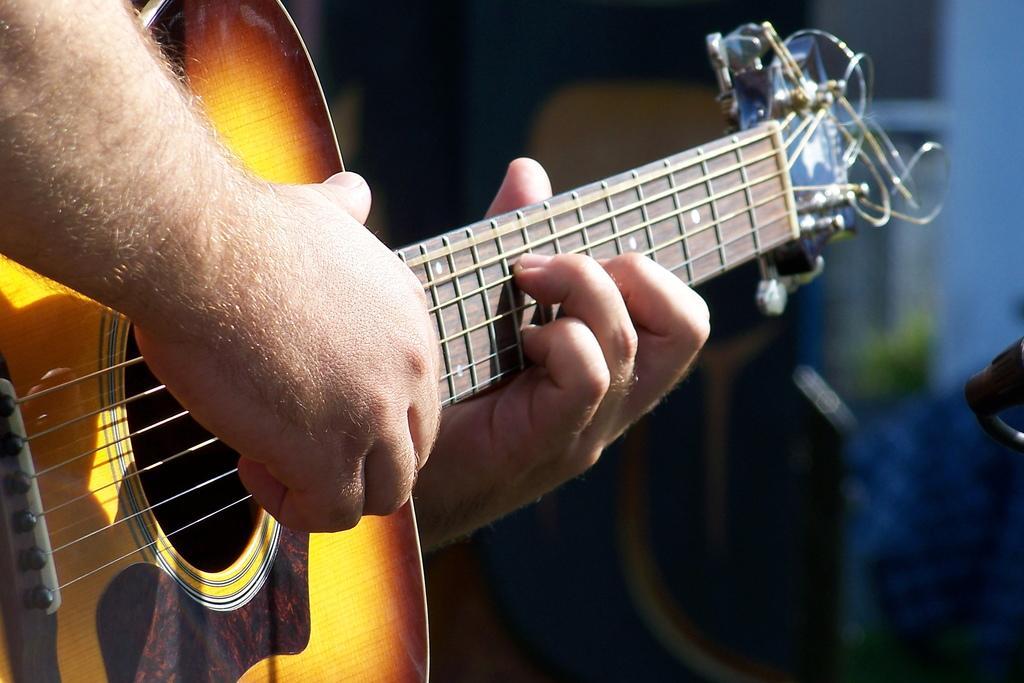Can you describe this image briefly? A person is playing a guitar. 